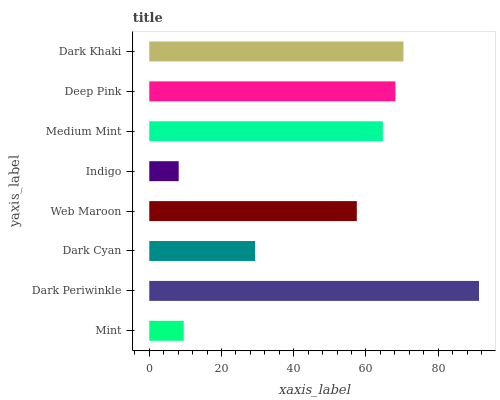Is Indigo the minimum?
Answer yes or no. Yes. Is Dark Periwinkle the maximum?
Answer yes or no. Yes. Is Dark Cyan the minimum?
Answer yes or no. No. Is Dark Cyan the maximum?
Answer yes or no. No. Is Dark Periwinkle greater than Dark Cyan?
Answer yes or no. Yes. Is Dark Cyan less than Dark Periwinkle?
Answer yes or no. Yes. Is Dark Cyan greater than Dark Periwinkle?
Answer yes or no. No. Is Dark Periwinkle less than Dark Cyan?
Answer yes or no. No. Is Medium Mint the high median?
Answer yes or no. Yes. Is Web Maroon the low median?
Answer yes or no. Yes. Is Dark Cyan the high median?
Answer yes or no. No. Is Dark Cyan the low median?
Answer yes or no. No. 